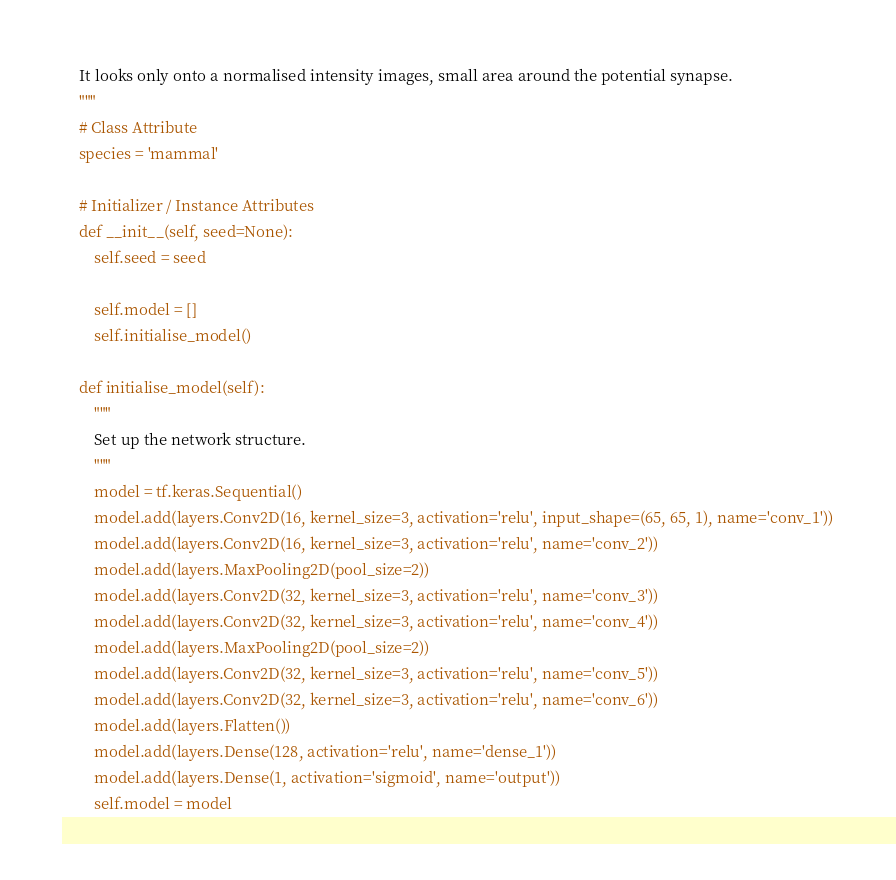<code> <loc_0><loc_0><loc_500><loc_500><_Python_>    It looks only onto a normalised intensity images, small area around the potential synapse.
    """
    # Class Attribute
    species = 'mammal'

    # Initializer / Instance Attributes
    def __init__(self, seed=None):
        self.seed = seed

        self.model = []
        self.initialise_model()

    def initialise_model(self):
        """
        Set up the network structure.
        """
        model = tf.keras.Sequential()
        model.add(layers.Conv2D(16, kernel_size=3, activation='relu', input_shape=(65, 65, 1), name='conv_1'))
        model.add(layers.Conv2D(16, kernel_size=3, activation='relu', name='conv_2'))
        model.add(layers.MaxPooling2D(pool_size=2))
        model.add(layers.Conv2D(32, kernel_size=3, activation='relu', name='conv_3'))
        model.add(layers.Conv2D(32, kernel_size=3, activation='relu', name='conv_4'))
        model.add(layers.MaxPooling2D(pool_size=2))
        model.add(layers.Conv2D(32, kernel_size=3, activation='relu', name='conv_5'))
        model.add(layers.Conv2D(32, kernel_size=3, activation='relu', name='conv_6'))
        model.add(layers.Flatten())
        model.add(layers.Dense(128, activation='relu', name='dense_1'))
        model.add(layers.Dense(1, activation='sigmoid', name='output'))
        self.model = model

</code> 